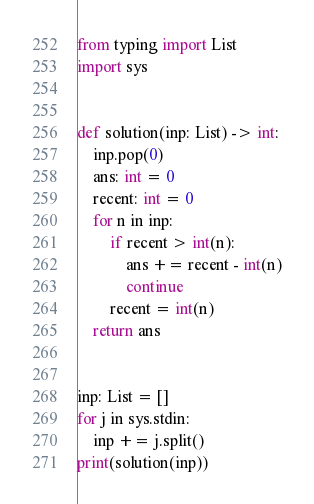<code> <loc_0><loc_0><loc_500><loc_500><_Python_>from typing import List
import sys


def solution(inp: List) -> int:
    inp.pop(0)
    ans: int = 0
    recent: int = 0
    for n in inp:
        if recent > int(n):
            ans += recent - int(n)
            continue
        recent = int(n)
    return ans


inp: List = []
for j in sys.stdin:
    inp += j.split()
print(solution(inp))
</code> 